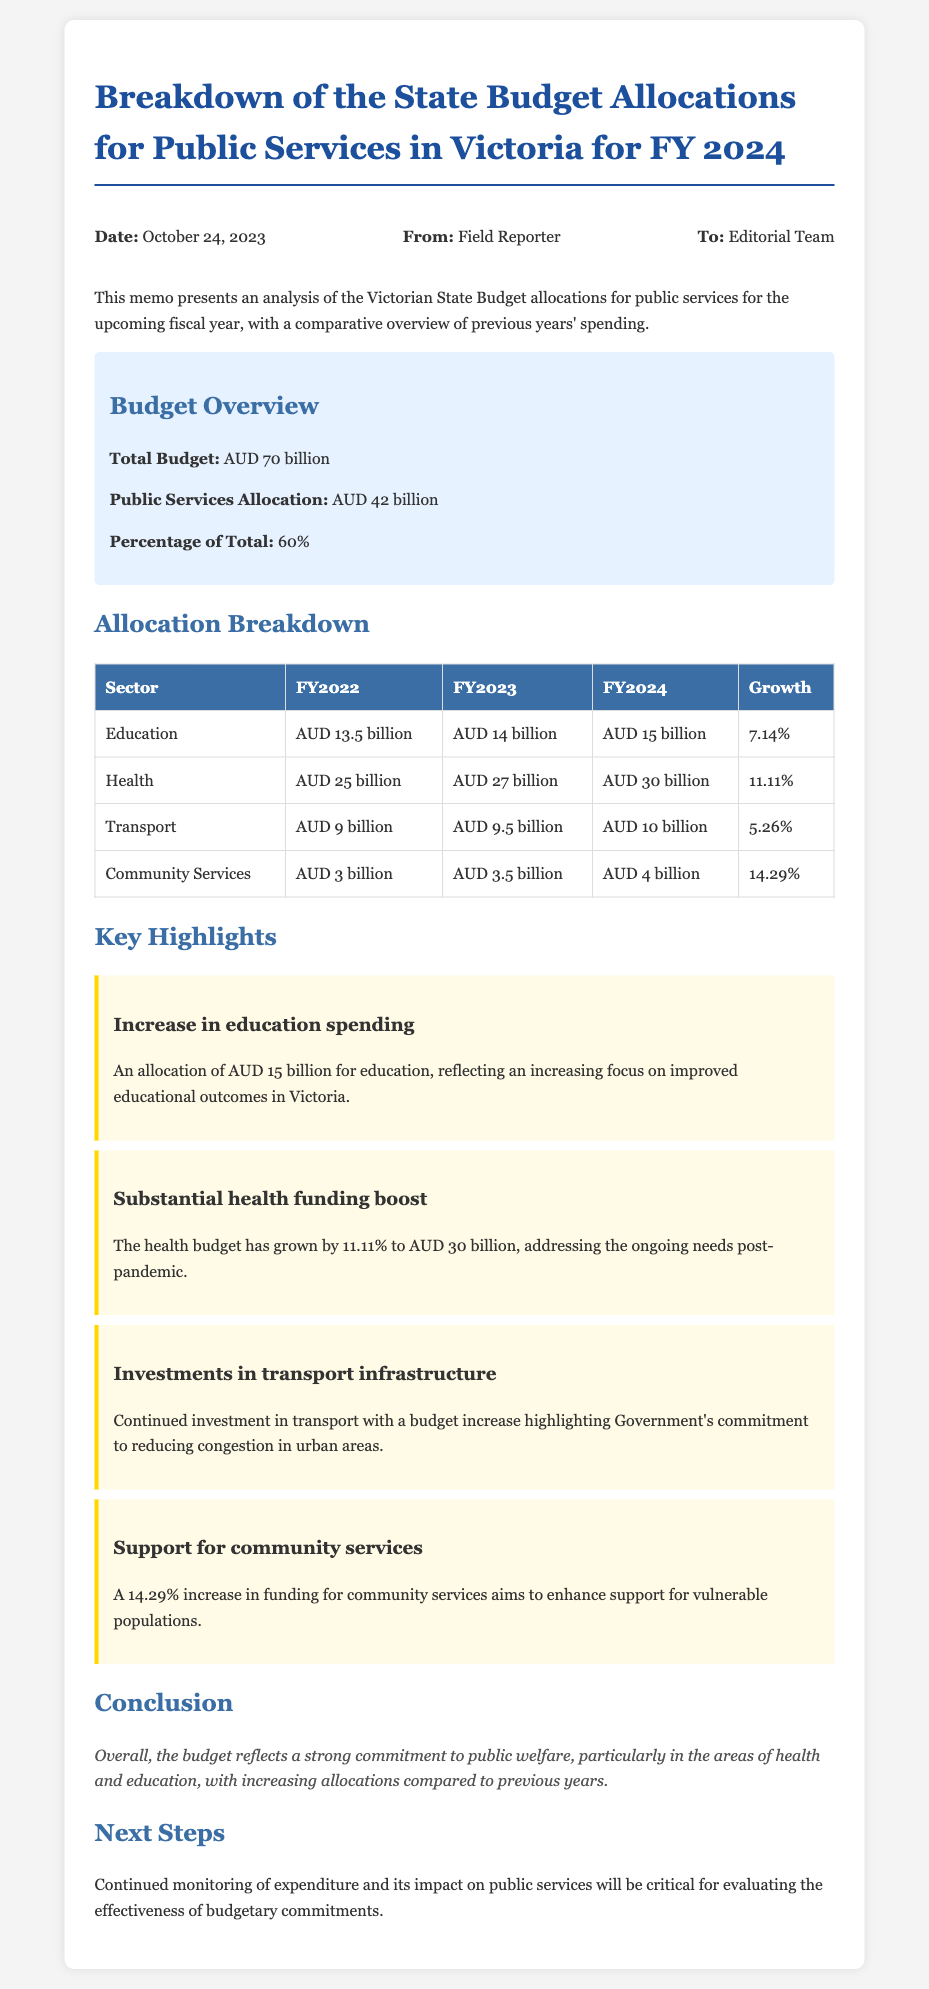What is the total budget for FY 2024? The total budget is mentioned in the document as AUD 70 billion.
Answer: AUD 70 billion What is the public services allocation for FY 2024? The document states that the public services allocation is AUD 42 billion.
Answer: AUD 42 billion How much is allocated to health in FY 2024? The allocation for health in FY 2024 is listed as AUD 30 billion.
Answer: AUD 30 billion What is the percentage of the public services allocation compared to the total budget? The document specifies that the percentage of the public services allocation is 60%.
Answer: 60% Which sector has the highest spending increase from FY 2023 to FY 2024? The reasoning can be derived from the growth percentages, where community services has the highest at 14.29%.
Answer: Community Services How did education spending change from FY 2022 to FY 2024? The document notes that education spending increased from AUD 13.5 billion in FY 2022 to AUD 15 billion in FY 2024.
Answer: Increased What date was the memo created? The memo includes the date as October 24, 2023.
Answer: October 24, 2023 What does the conclusion of the memo emphasize? The conclusion emphasizes a strong commitment to public welfare, particularly in health and education.
Answer: Strong commitment to public welfare What is the primary focus of the increase in the health budget? The document mentions that the boost in the health budget addresses ongoing needs post-pandemic.
Answer: Ongoing needs post-pandemic 